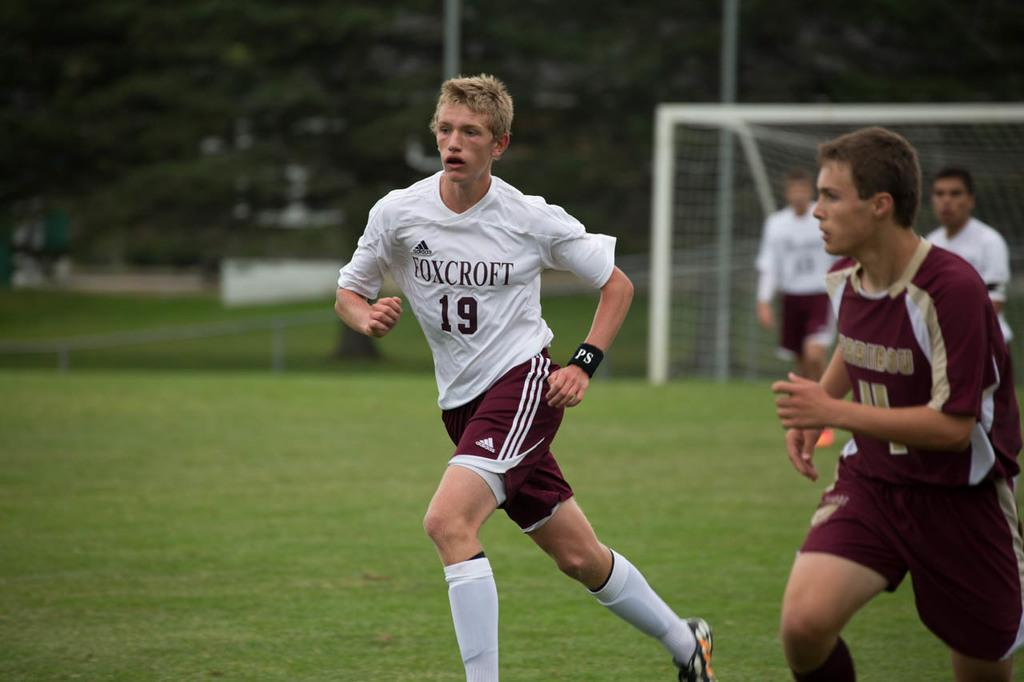What are the two people in the image doing? The two people in the image are running. What type of surface can be seen beneath the people? There is grass visible in the image. What can be seen in the background of the image? There are people, a net, poles, and trees in the background. What type of pump is visible in the image? There is no pump present in the image. How does the brake work on the people running in the image? The people running in the image do not have brakes, as they are human beings and not vehicles. 